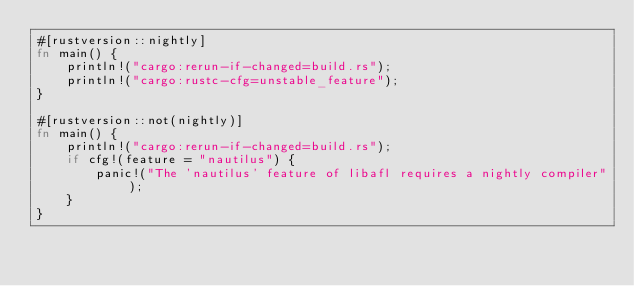Convert code to text. <code><loc_0><loc_0><loc_500><loc_500><_Rust_>#[rustversion::nightly]
fn main() {
    println!("cargo:rerun-if-changed=build.rs");
    println!("cargo:rustc-cfg=unstable_feature");
}

#[rustversion::not(nightly)]
fn main() {
    println!("cargo:rerun-if-changed=build.rs");
    if cfg!(feature = "nautilus") {
        panic!("The 'nautilus' feature of libafl requires a nightly compiler");
    }
}
</code> 